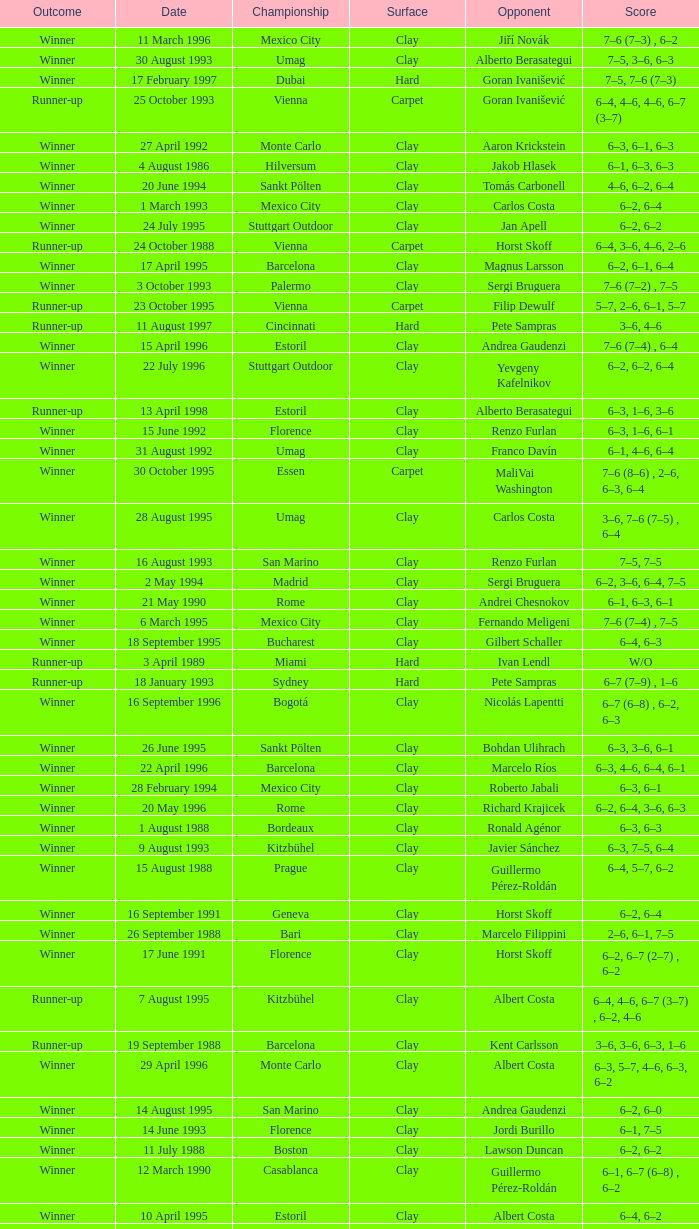Who is the opponent on 18 january 1993? Pete Sampras. 